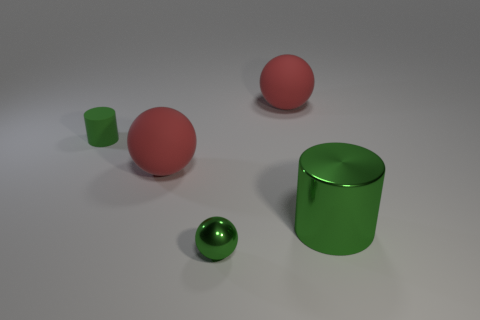Add 2 small shiny things. How many objects exist? 7 Subtract all spheres. How many objects are left? 2 Add 4 big rubber things. How many big rubber things are left? 6 Add 1 green metal balls. How many green metal balls exist? 2 Subtract 0 blue blocks. How many objects are left? 5 Subtract all small red cylinders. Subtract all matte cylinders. How many objects are left? 4 